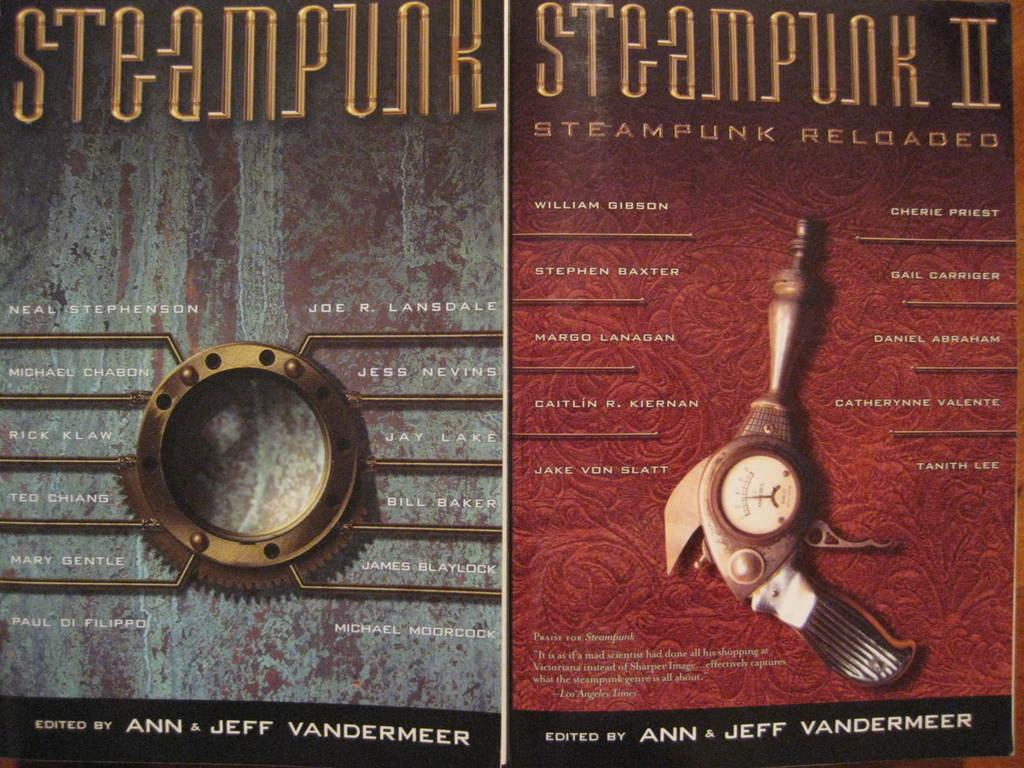<image>
Relay a brief, clear account of the picture shown. The cover of Steampunk and Steampunk II Reloaded. 